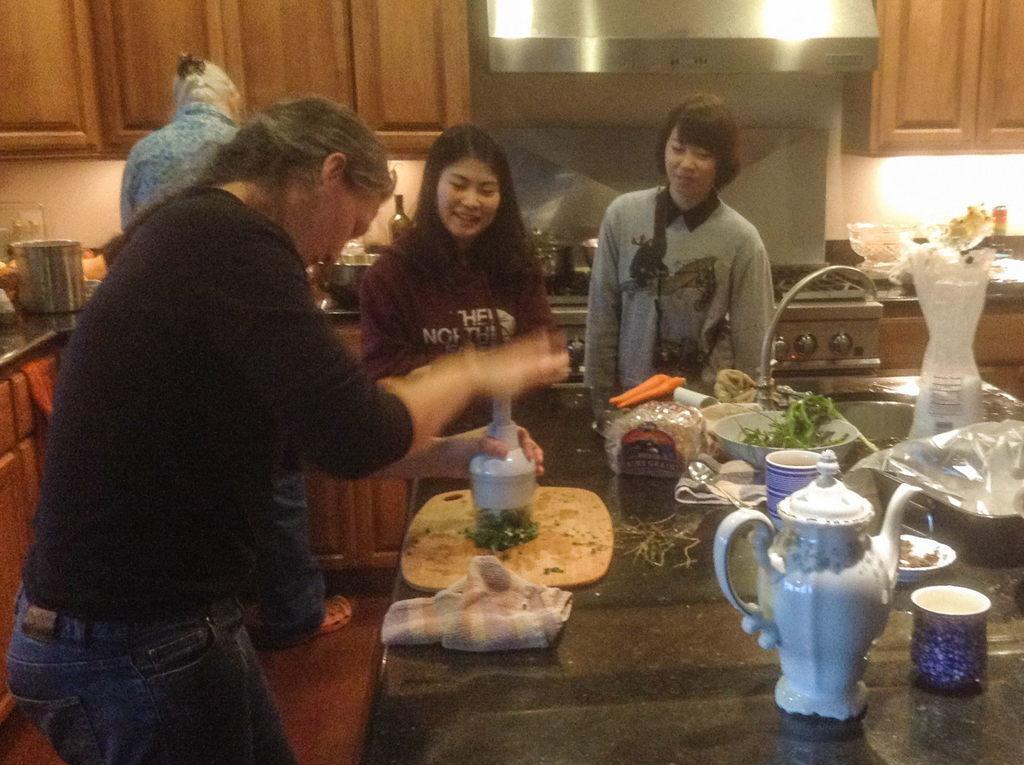Can you describe this image briefly? In this image, we can see four people are standing on the floor. Few are smiling. Here a person is holding some object. At the bottom, there is a table few objects are placed on it. Background there is a kitchen platform. So many things, items, stove we can see. Here we can see cupboards, chimney and wall. 